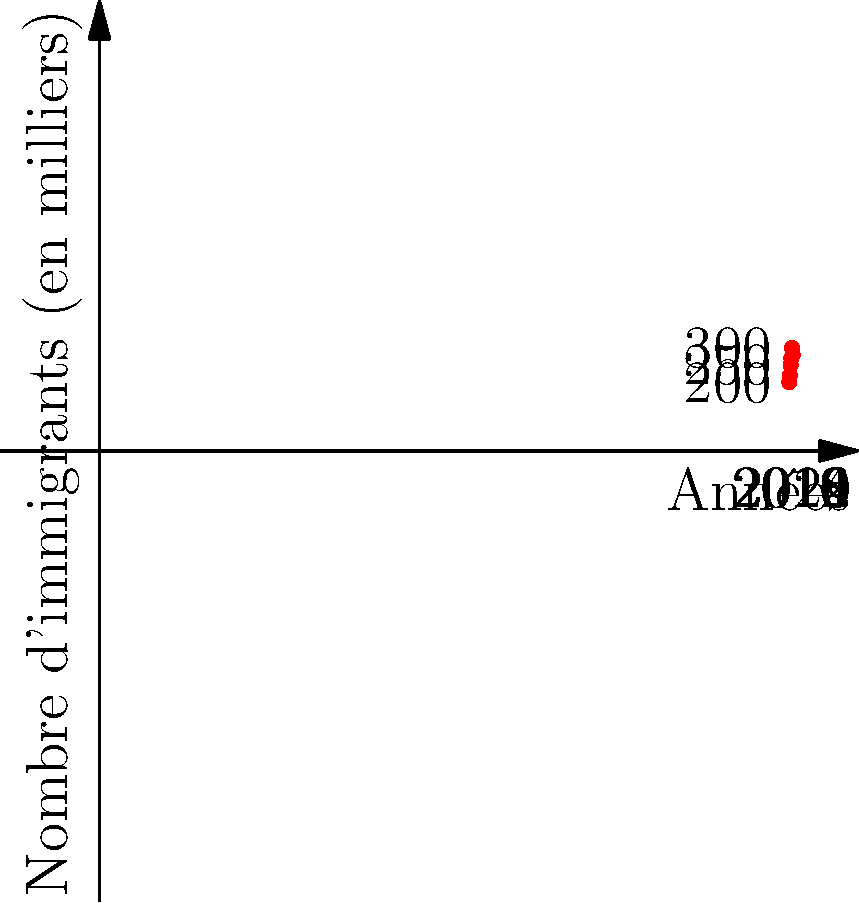Le graphique ci-dessus montre l'évolution du nombre d'immigrants en France de 2010 à 2020. Quelle est la différence entre le nombre d'immigrants en 2018 et en 2010 ? Pour résoudre ce problème, nous devons suivre ces étapes :

1. Identifier le nombre d'immigrants en 2018 :
   En 2018, le graphique montre 300 000 immigrants.

2. Identifier le nombre d'immigrants en 2010 :
   En 2010, le graphique montre 200 000 immigrants.

3. Calculer la différence :
   $300 000 - 200 000 = 100 000$

La différence entre le nombre d'immigrants en 2018 et en 2010 est donc de 100 000.

Il est important de noter que cette augmentation représente une tendance significative dans l'immigration en France sur cette période de 8 ans, ce qui pourrait avoir des implications sociologiques et psychologiques intéressantes à étudier.
Answer: 100 000 